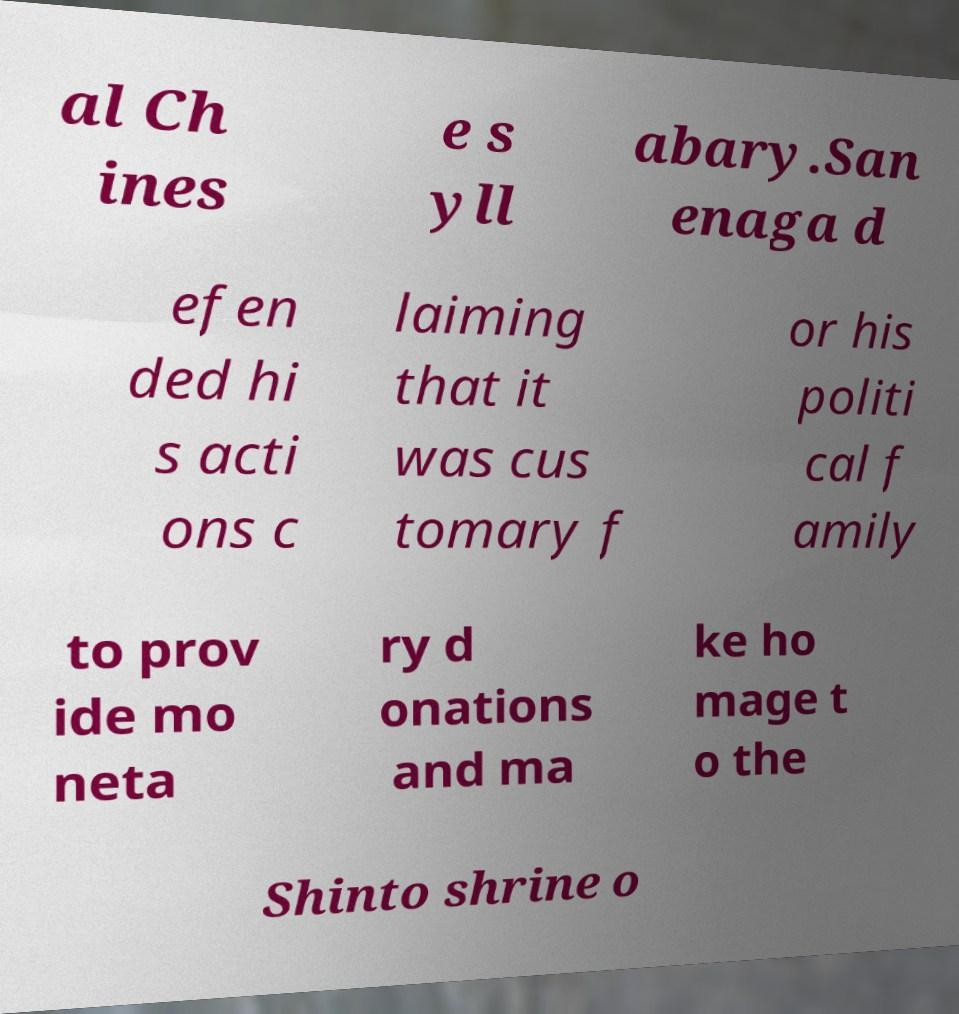For documentation purposes, I need the text within this image transcribed. Could you provide that? al Ch ines e s yll abary.San enaga d efen ded hi s acti ons c laiming that it was cus tomary f or his politi cal f amily to prov ide mo neta ry d onations and ma ke ho mage t o the Shinto shrine o 